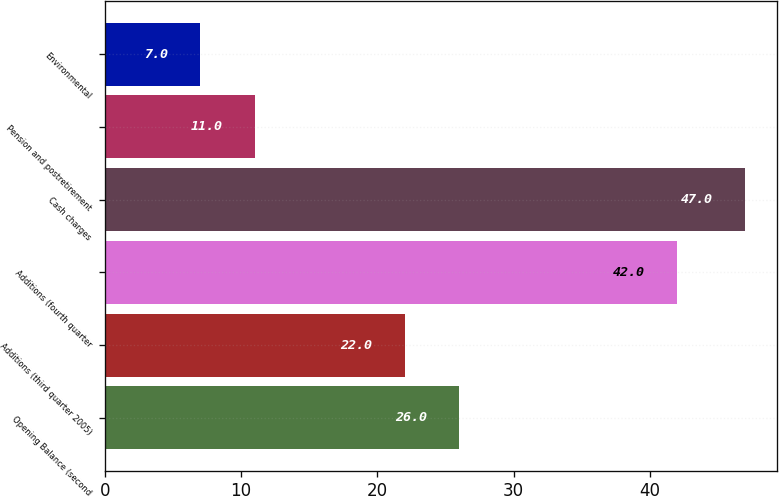Convert chart to OTSL. <chart><loc_0><loc_0><loc_500><loc_500><bar_chart><fcel>Opening Balance (second<fcel>Additions (third quarter 2005)<fcel>Additions (fourth quarter<fcel>Cash charges<fcel>Pension and postretirement<fcel>Environmental<nl><fcel>26<fcel>22<fcel>42<fcel>47<fcel>11<fcel>7<nl></chart> 